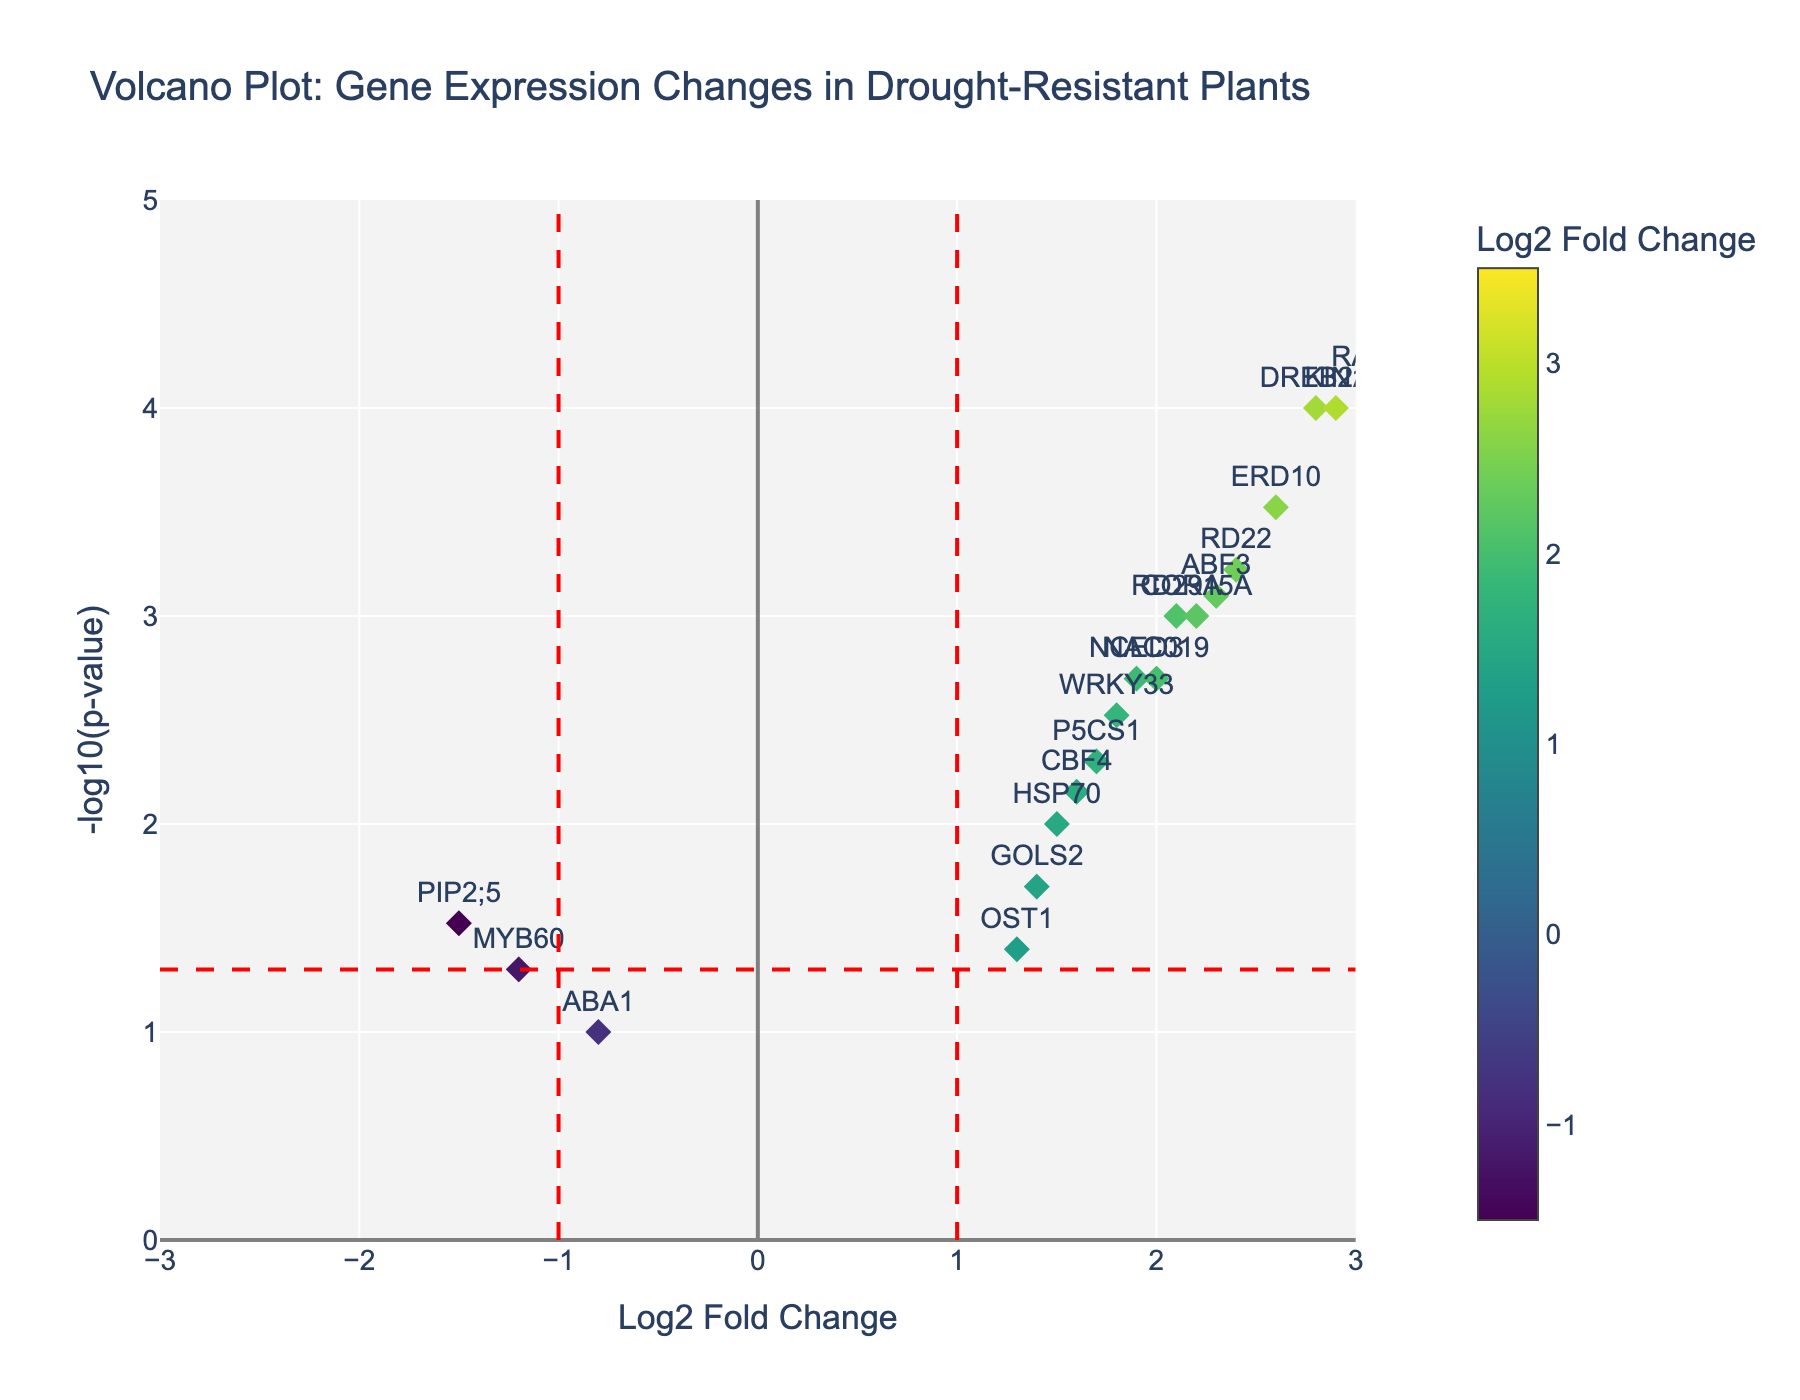What is the title of the figure? The title of the figure is prominently displayed at the top and describes what the plot represents.
Answer: Volcano Plot: Gene Expression Changes in Drought-Resistant Plants How many genes have a Log2 Fold Change greater than 1 and a -log10(p-value) greater than 2? To answer this, you need to find the points where both Log2 Fold Change (x-axis) > 1 and -log10(p-value) (y-axis) > 2. Count these points.
Answer: 12 Which gene has the highest -log10(p-value) and what is its corresponding Log2 Fold Change? Look for the point that has the maximum value on the y-axis and note the corresponding x-axis value and gene label.
Answer: LEA, 3.5 Are there any genes with a Log2 Fold Change less than -1? Check the left side of the vertical dashed line at x = -1 to see if there are any points, and note their genes.
Answer: Yes, MYB60 and PIP2;5 What is the significance threshold for p-value in terms of -log10(p-value), and how is it depicted in the plot? The threshold is typically shown as a horizontal dashed line; identify its y-axis value.
Answer: 1.3 (corresponds to p = 0.05) Which gene shows a Log2 Fold Change closest to zero? Look for the point that is nearest to the y-axis (x = 0) and identify the gene.
Answer: ABA1 Compare the Log2 Fold Change and -log10(p-value) for the genes DREB2A and ABF3. Which gene shows a higher expression change and which one is statistically more significant? DREB2A has Log2 Fold Change of 2.8 and -log10(p-value) of 4, while ABF3 has 2.3 and 3.1 respectively. Compare these values.
Answer: DREB2A shows higher expression change, LEA is more statistically significant How many genes have a p-value below 0.001? Convert the p-value threshold to -log10(0.001) = 3, then count the points with y-axis values above 3.
Answer: 4 Which gene has the lowest Log2 Fold Change among those that are statistically significant (p-value < 0.05)? Filter genes with y-values above 1.3 (significance threshold), then find the minimum x-value and the corresponding gene.
Answer: MYB60, -1.2 How many genes have a positive Log2 Fold Change and are statistically significant (p < 0.05)? Count the points to the right of x = 0 and above the horizontal significance threshold line.
Answer: 17 